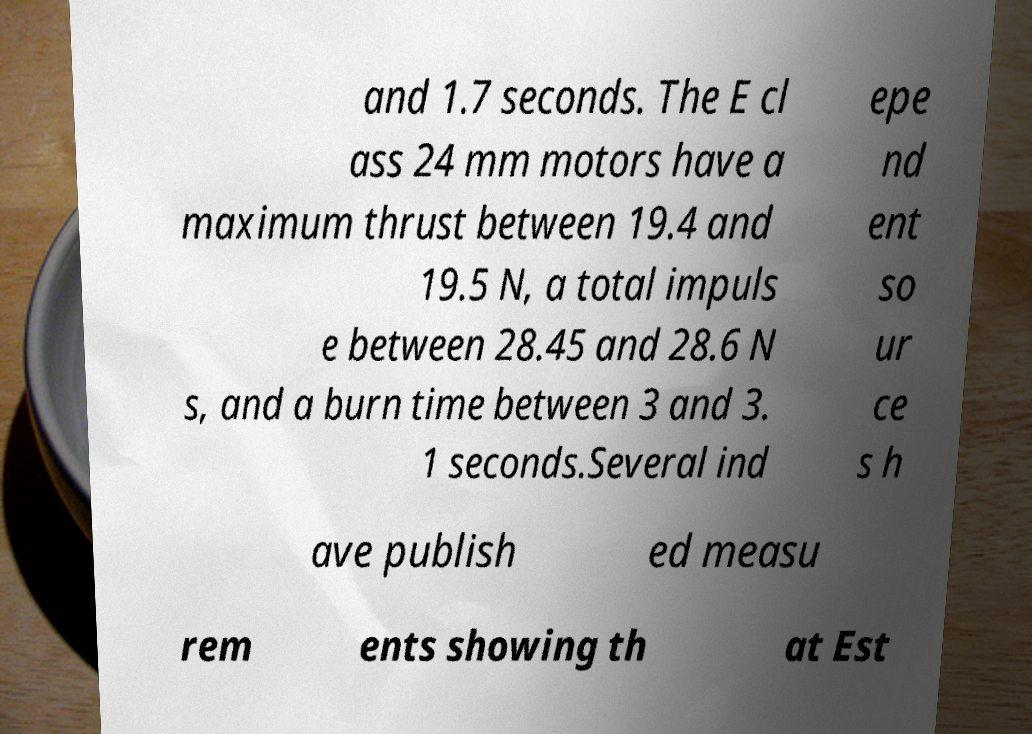Could you assist in decoding the text presented in this image and type it out clearly? and 1.7 seconds. The E cl ass 24 mm motors have a maximum thrust between 19.4 and 19.5 N, a total impuls e between 28.45 and 28.6 N s, and a burn time between 3 and 3. 1 seconds.Several ind epe nd ent so ur ce s h ave publish ed measu rem ents showing th at Est 